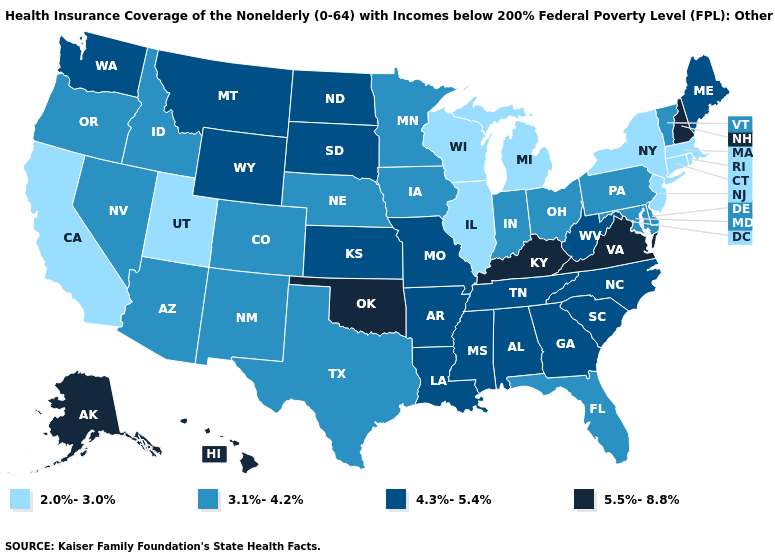Does the first symbol in the legend represent the smallest category?
Give a very brief answer. Yes. Among the states that border Louisiana , which have the highest value?
Write a very short answer. Arkansas, Mississippi. What is the value of Idaho?
Answer briefly. 3.1%-4.2%. Does South Dakota have the lowest value in the MidWest?
Give a very brief answer. No. What is the lowest value in the Northeast?
Keep it brief. 2.0%-3.0%. Among the states that border South Dakota , does Nebraska have the lowest value?
Give a very brief answer. Yes. Among the states that border Kansas , does Nebraska have the highest value?
Keep it brief. No. Does New Hampshire have a lower value than Mississippi?
Answer briefly. No. Does Idaho have a lower value than Alaska?
Be succinct. Yes. How many symbols are there in the legend?
Keep it brief. 4. How many symbols are there in the legend?
Short answer required. 4. What is the lowest value in states that border Washington?
Give a very brief answer. 3.1%-4.2%. Does Vermont have the lowest value in the Northeast?
Concise answer only. No. Which states have the lowest value in the MidWest?
Answer briefly. Illinois, Michigan, Wisconsin. Name the states that have a value in the range 4.3%-5.4%?
Quick response, please. Alabama, Arkansas, Georgia, Kansas, Louisiana, Maine, Mississippi, Missouri, Montana, North Carolina, North Dakota, South Carolina, South Dakota, Tennessee, Washington, West Virginia, Wyoming. 